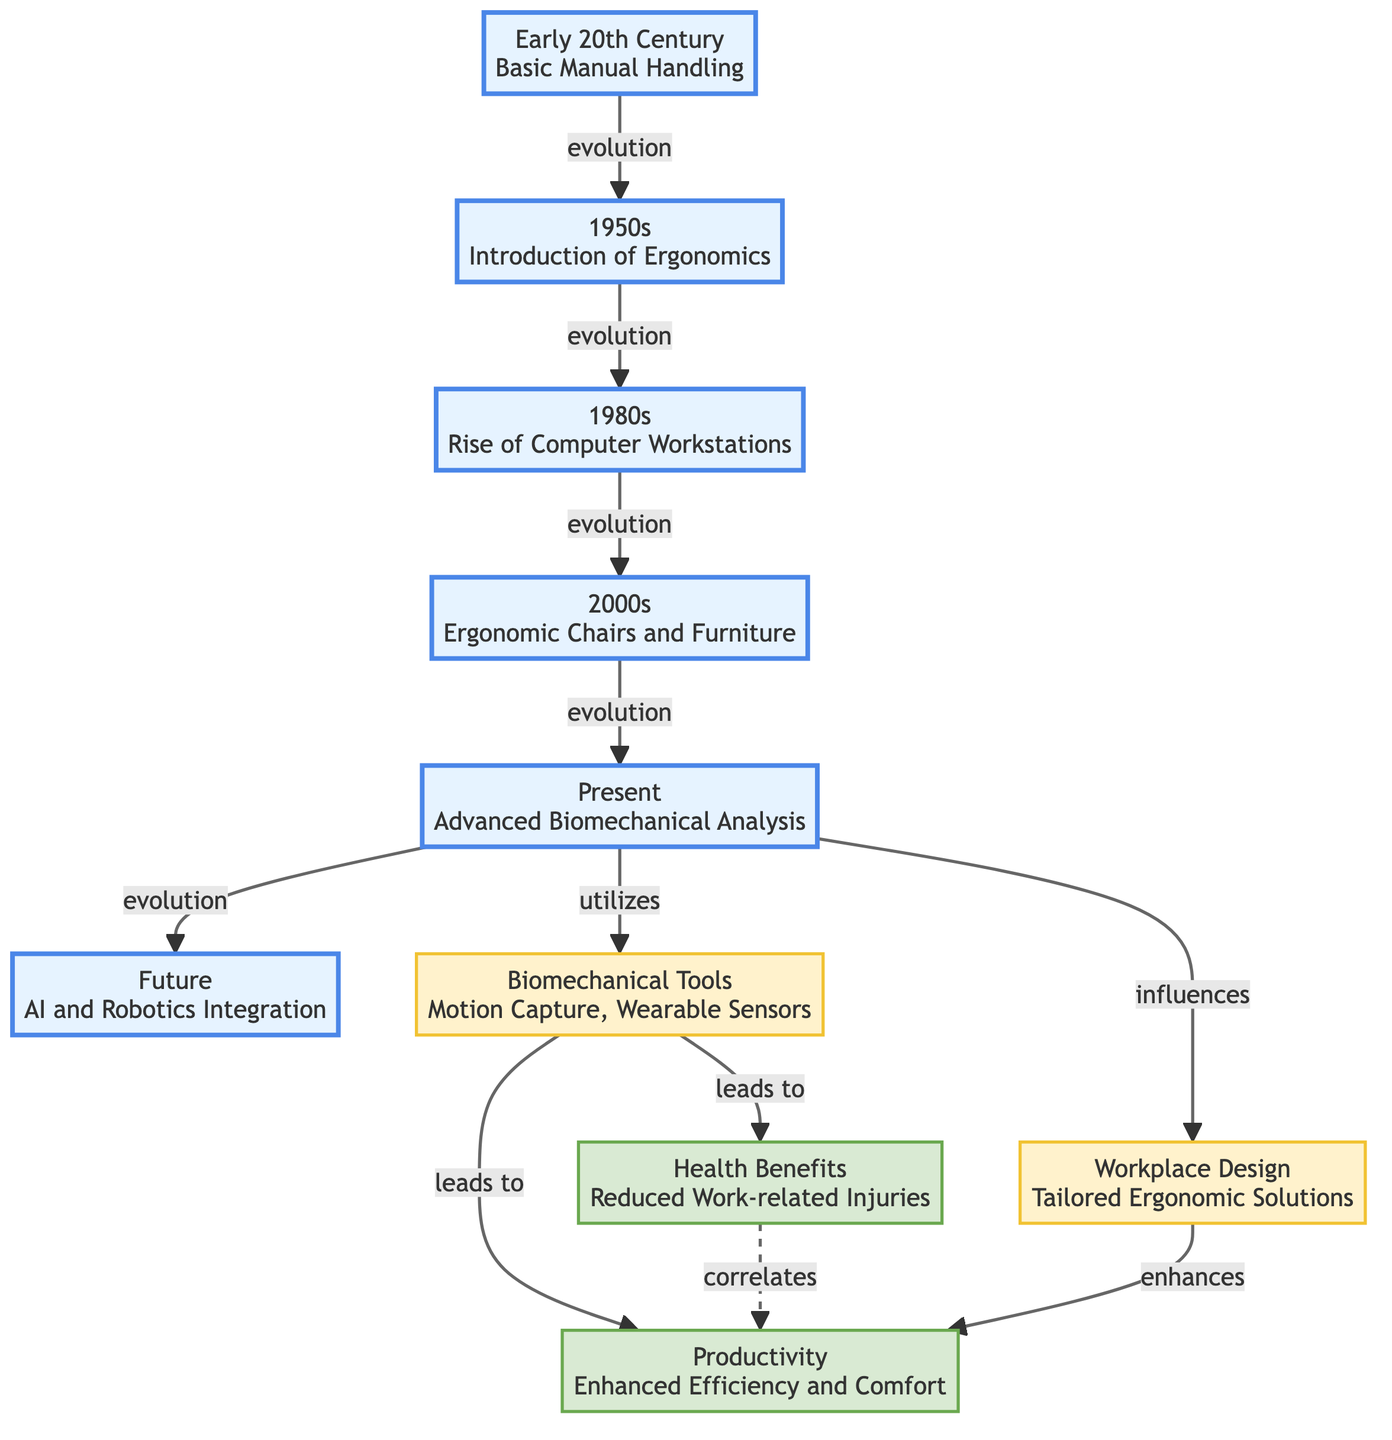What era is associated with the introduction of ergonomics? The diagram indicates that the introduction of ergonomics corresponds to the year 1950s in node N2.
Answer: 1950s How many total eras are shown in this diagram? The diagram displays five eras from N1 to N6, representing different time periods in the evolution of workplace ergonomics.
Answer: 5 Which biomechanical tools are mentioned in the diagram? Node N7 indicates that the tools referred to are motion capture and wearable sensors.
Answer: Motion Capture, Wearable Sensors What is the outcome correlated with reduced work-related injuries? The relationship shown in the diagram indicates that reduced work-related injuries (N8) correlates with enhanced efficiency and comfort (N9).
Answer: Enhanced Efficiency and Comfort How does advanced biomechanical analysis influence workplace design? The diagram shows that advanced biomechanical analysis (N5) influences tailored ergonomic solutions (N10), indicating a link between these nodes.
Answer: Tailored Ergonomic Solutions What type of integration is expected for the future of workplace ergonomics? According to node N6, the future of workplace ergonomics is expected to integrate AI and robotics.
Answer: AI and Robotics Integration What are the two main benefits listed from biomechanical tools? The diagram indicates two outcomes from the use of biomechanical tools: reduced work-related injuries (N8) and enhanced efficiency and comfort (N9).
Answer: Reduced Work-related Injuries, Enhanced Efficiency and Comfort How many links lead from the present to the future in the diagram? The diagram shows four links emerging from the present era (N5) to the future (N6) and various nodes related to tools and outcomes.
Answer: 4 What leads to tailored ergonomic solutions in the evolution of workplace ergonomics? The diagram clearly shows that advancements in biomechanical analysis (N5) influence the development of tailored ergonomic solutions (N10).
Answer: Advanced Biomechanical Analysis 